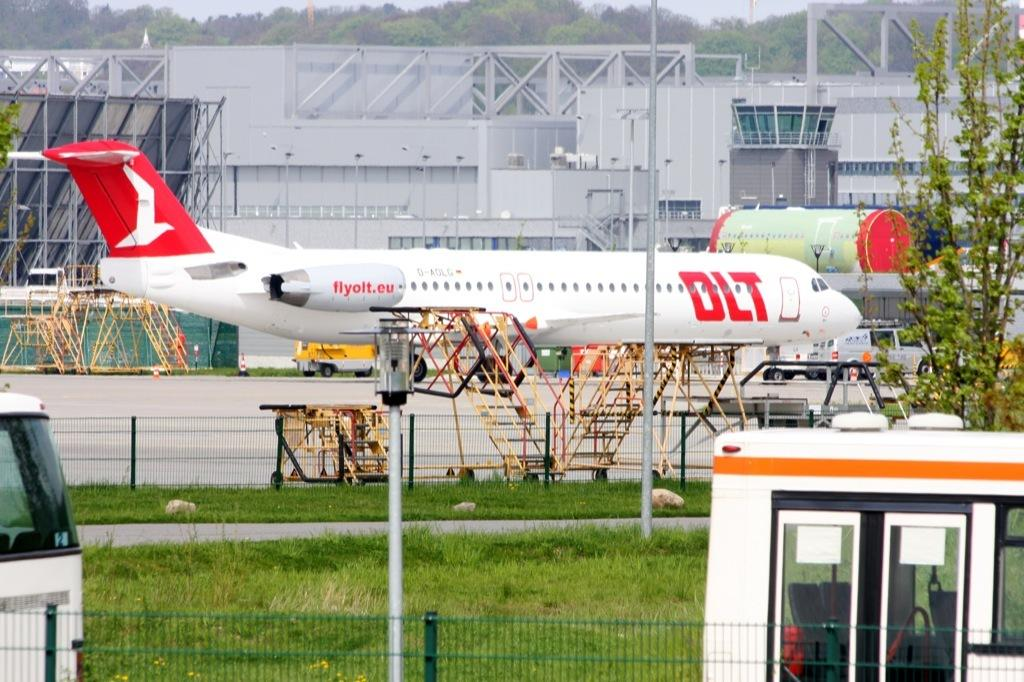<image>
Write a terse but informative summary of the picture. The white plane has DLT in large red letters and flyolt.eu in smaller lettering. 